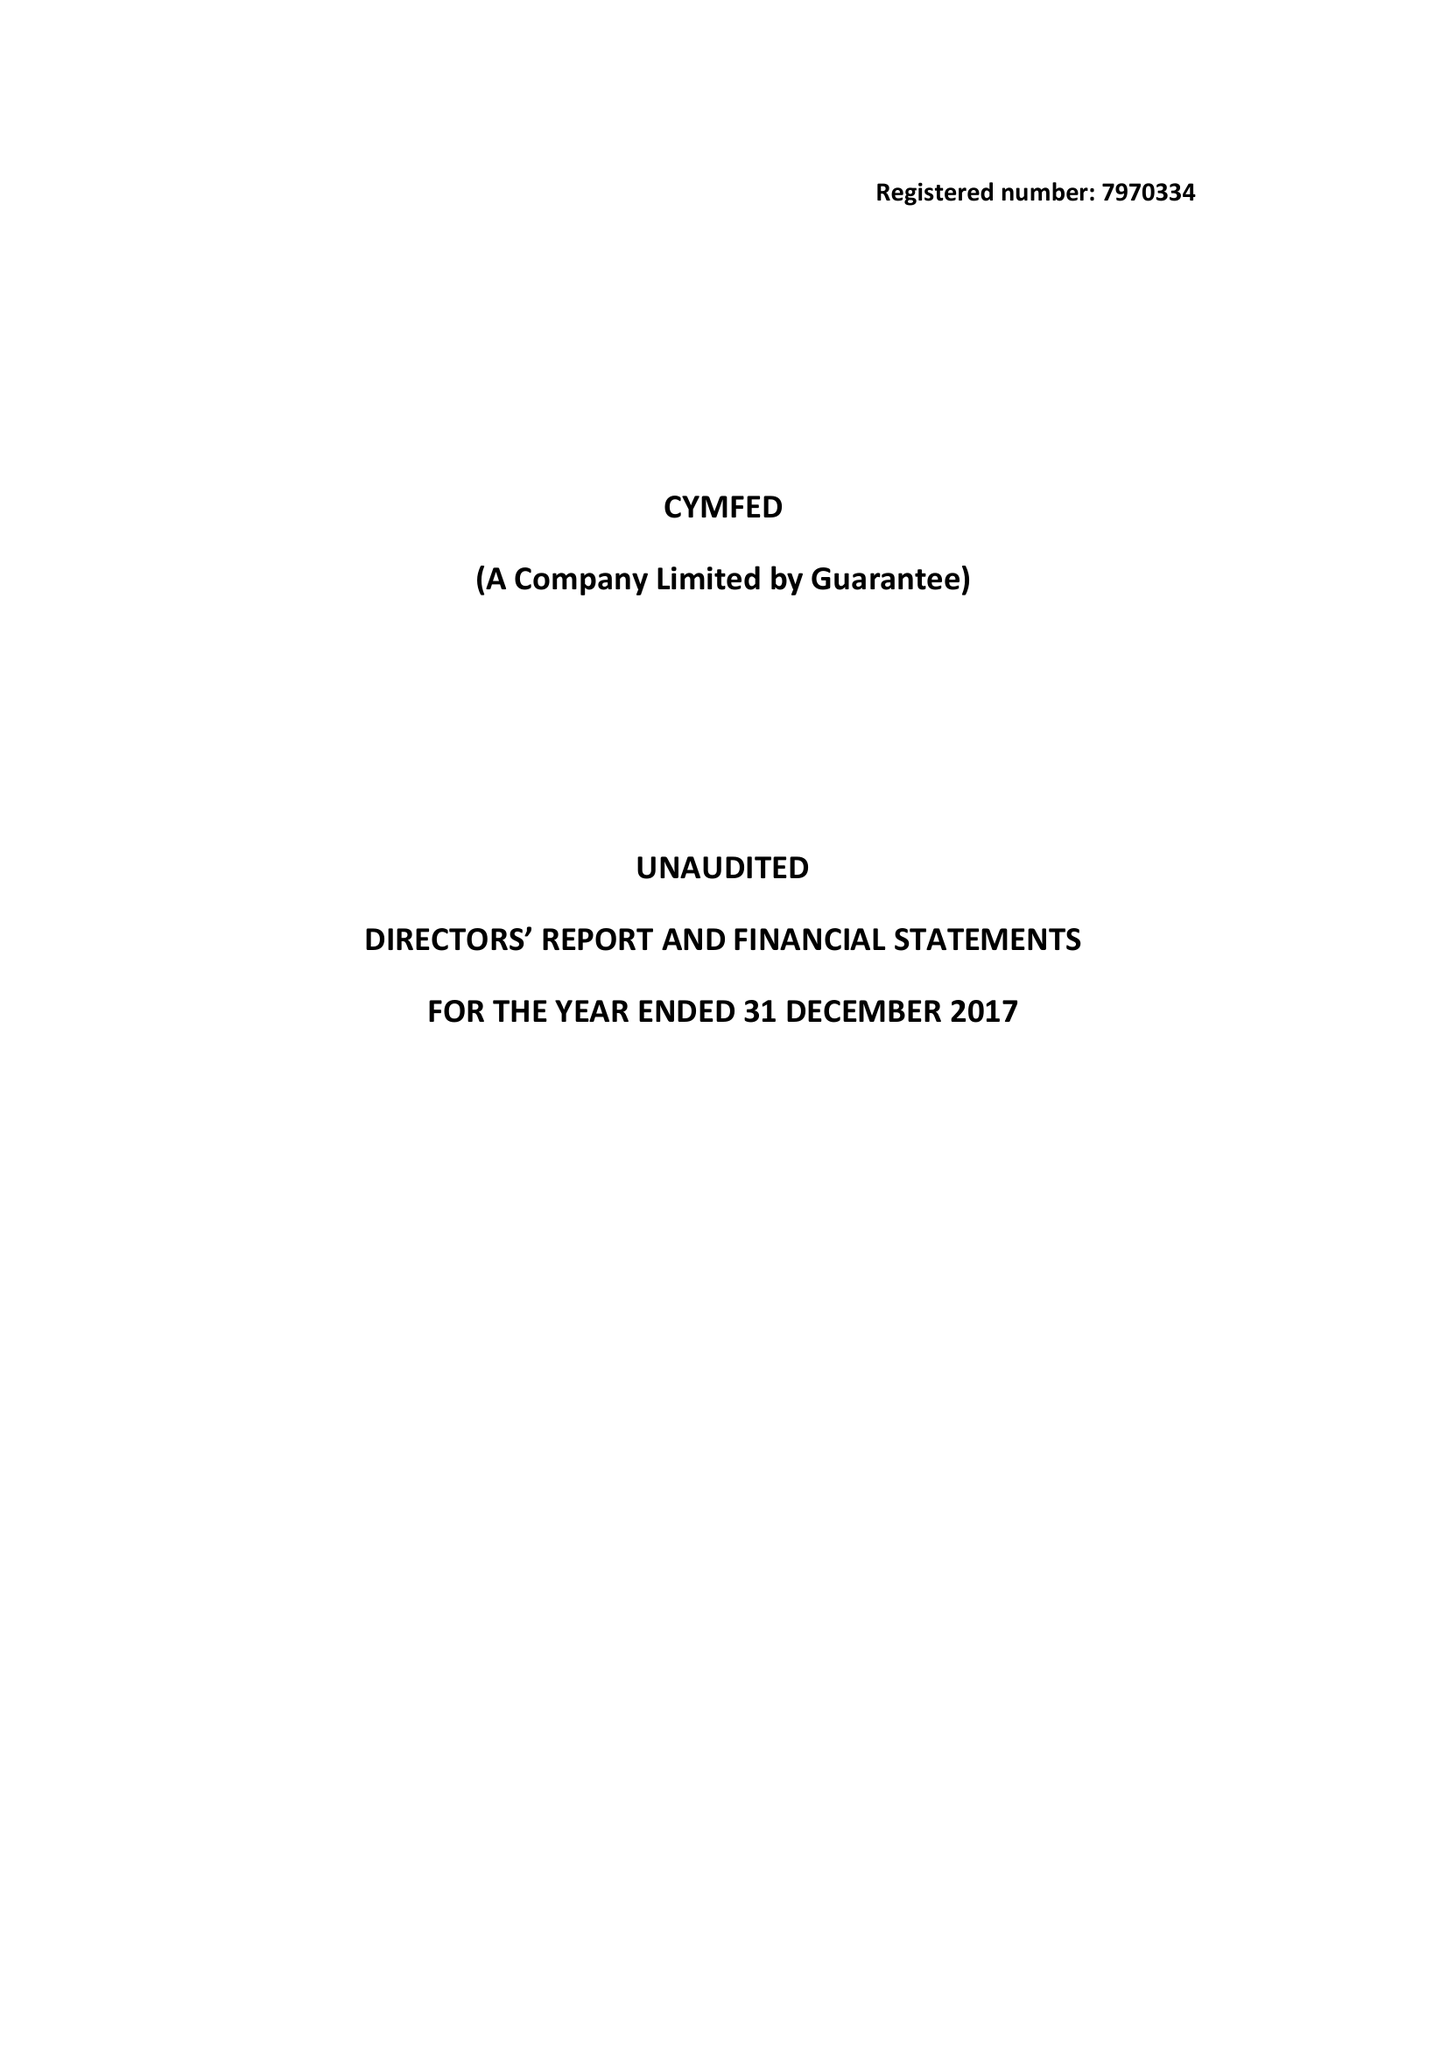What is the value for the charity_name?
Answer the question using a single word or phrase. Cymfed 